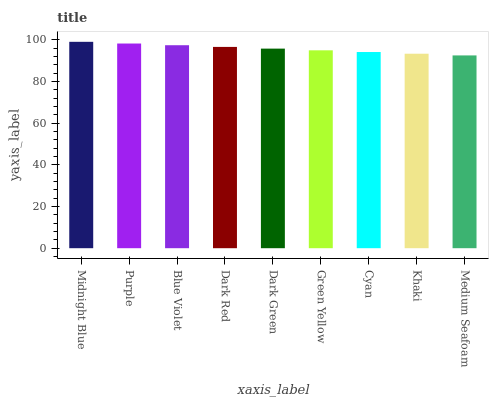Is Medium Seafoam the minimum?
Answer yes or no. Yes. Is Midnight Blue the maximum?
Answer yes or no. Yes. Is Purple the minimum?
Answer yes or no. No. Is Purple the maximum?
Answer yes or no. No. Is Midnight Blue greater than Purple?
Answer yes or no. Yes. Is Purple less than Midnight Blue?
Answer yes or no. Yes. Is Purple greater than Midnight Blue?
Answer yes or no. No. Is Midnight Blue less than Purple?
Answer yes or no. No. Is Dark Green the high median?
Answer yes or no. Yes. Is Dark Green the low median?
Answer yes or no. Yes. Is Khaki the high median?
Answer yes or no. No. Is Blue Violet the low median?
Answer yes or no. No. 